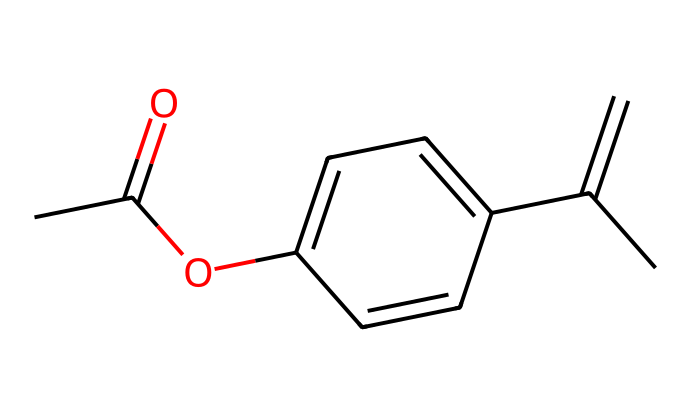What is the functional group present in this compound? The presence of the carbonyl (C=O) and the ether (C-O-C) linkage indicates that there is an ester functional group in the chemical structure.
Answer: ester How many rings are present in the chemical structure? The provided SMILES representation shows one cyclic structure, indicated by the 'C1' and 'C=C' connections forming a ring.
Answer: one What is the total number of carbon atoms in the compound? Counting the carbon atoms in the SMILES notation shows there are 11 carbon atoms in total represented in the structure.
Answer: eleven Does this compound exhibit chirality? The presence of a carbon atom bonded to four different groups (the asymmetric center) indicates that this compound does exhibit chirality.
Answer: yes What type of isomerism can be observed in this chemical? Due to the presence of a chiral center, this compound can exhibit configurational isomerism, specifically enantiomerism.
Answer: enantiomerism How many double bonds can be found in the structure? By examining the SMILES code, two double bonds are identified in the cyclohexene part of the compound.
Answer: two What type of hybridization is observed at the chiral center? The chiral carbon is bonded to four different groups implying it is sp3 hybridized, as it forms four single bonds.
Answer: sp3 